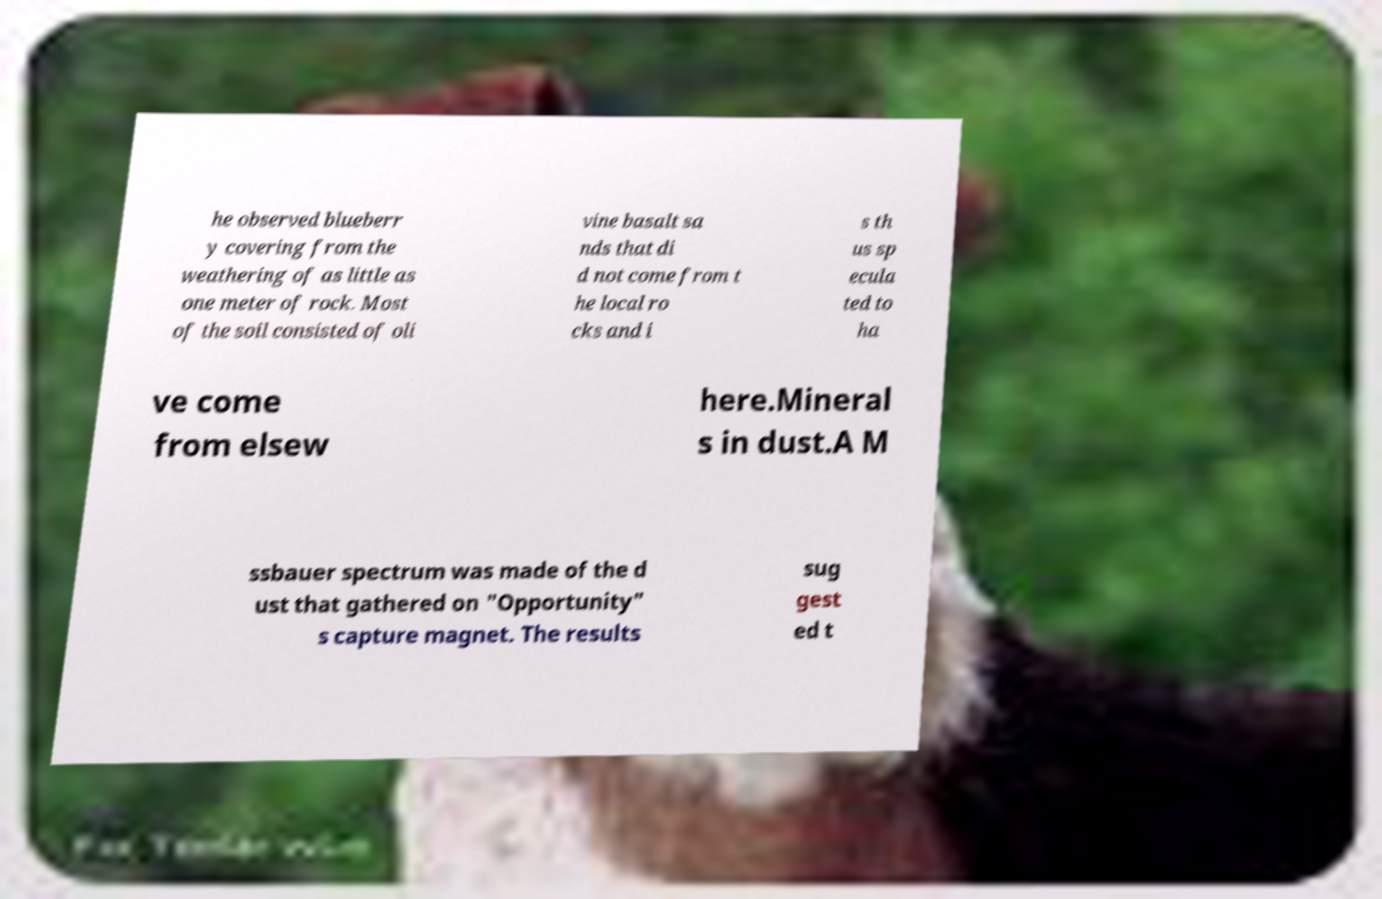I need the written content from this picture converted into text. Can you do that? he observed blueberr y covering from the weathering of as little as one meter of rock. Most of the soil consisted of oli vine basalt sa nds that di d not come from t he local ro cks and i s th us sp ecula ted to ha ve come from elsew here.Mineral s in dust.A M ssbauer spectrum was made of the d ust that gathered on "Opportunity" s capture magnet. The results sug gest ed t 